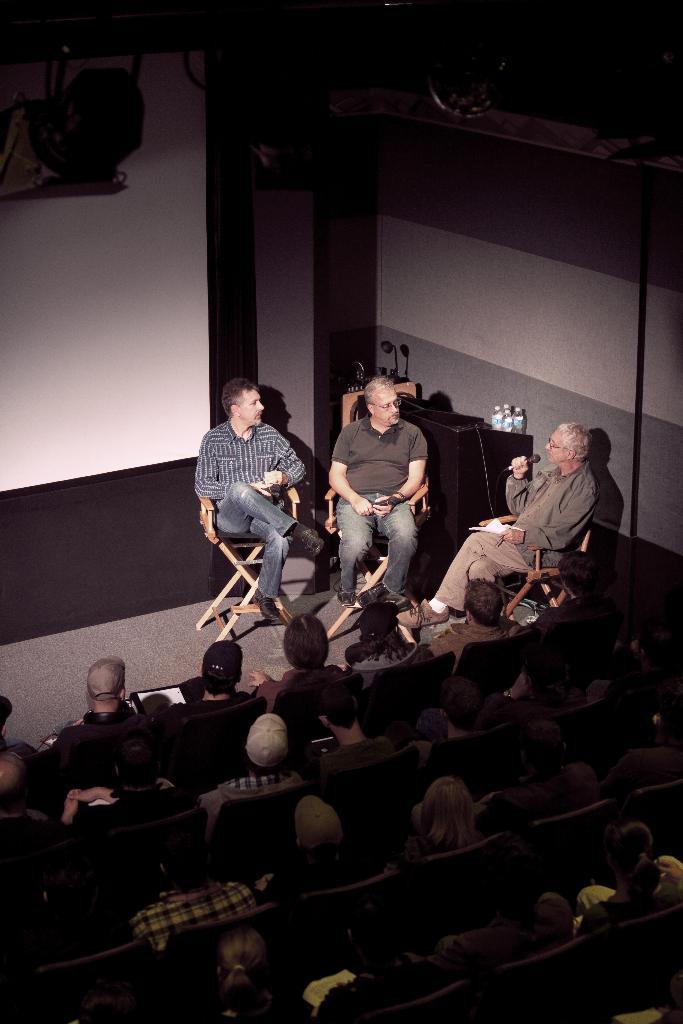Can you describe this image briefly? In the image we can see there are many people wearing clothes and they are sitting on the chair. This is a microphone, paper, white board, water bottles and the floor. 